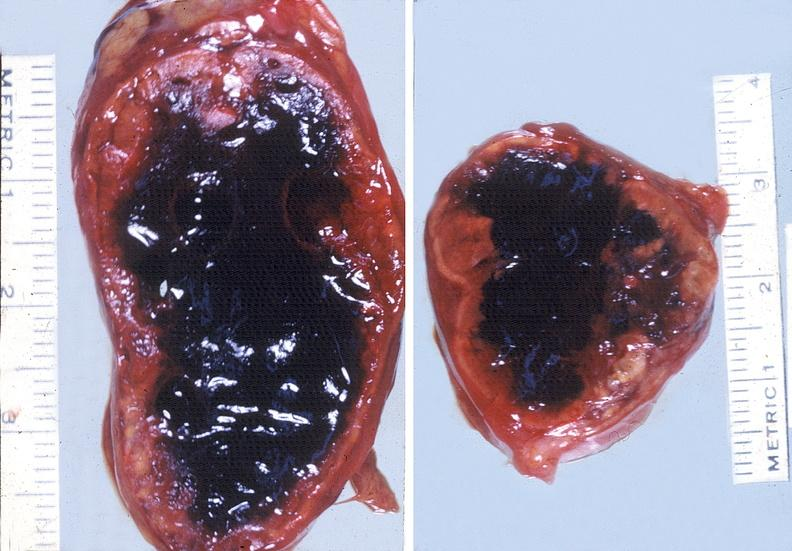s angiogram present?
Answer the question using a single word or phrase. No 